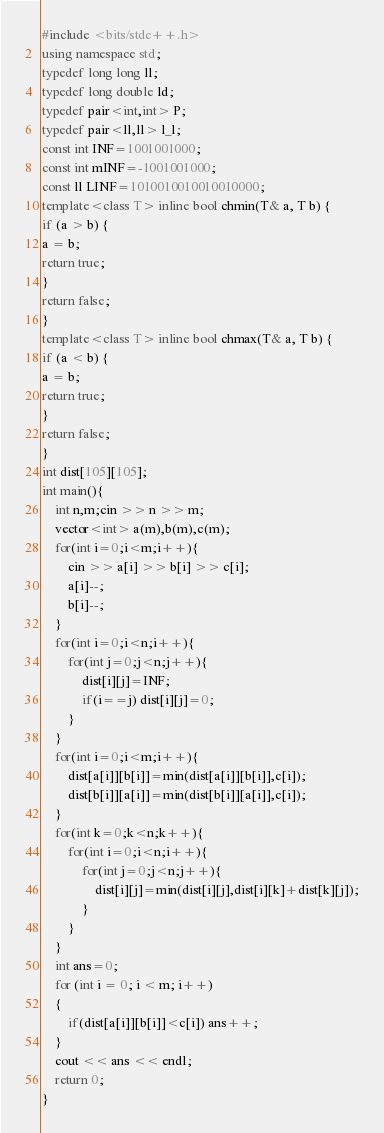<code> <loc_0><loc_0><loc_500><loc_500><_C++_>#include <bits/stdc++.h>
using namespace std;
typedef long long ll;
typedef long double ld;
typedef pair<int,int> P;
typedef pair<ll,ll> l_l;
const int INF=1001001000;
const int mINF=-1001001000;
const ll LINF=1010010010010010000;
template<class T> inline bool chmin(T& a, T b) {
if (a > b) {
a = b;
return true;
}
return false;
}
template<class T> inline bool chmax(T& a, T b) {
if (a < b) {
a = b;
return true;
}
return false;
}
int dist[105][105];
int main(){
    int n,m;cin >> n >> m;
    vector<int> a(m),b(m),c(m);
    for(int i=0;i<m;i++){
        cin >> a[i] >> b[i] >> c[i];
        a[i]--;
        b[i]--;
    }
    for(int i=0;i<n;i++){
        for(int j=0;j<n;j++){
            dist[i][j]=INF;
            if(i==j) dist[i][j]=0;
        }
    }
    for(int i=0;i<m;i++){
        dist[a[i]][b[i]]=min(dist[a[i]][b[i]],c[i]);
        dist[b[i]][a[i]]=min(dist[b[i]][a[i]],c[i]);
    }
    for(int k=0;k<n;k++){
        for(int i=0;i<n;i++){
            for(int j=0;j<n;j++){
                dist[i][j]=min(dist[i][j],dist[i][k]+dist[k][j]);
            }
        }
    }
    int ans=0;
    for (int i = 0; i < m; i++)
    {
        if(dist[a[i]][b[i]]<c[i]) ans++;
    }
    cout << ans << endl;
    return 0;
}</code> 